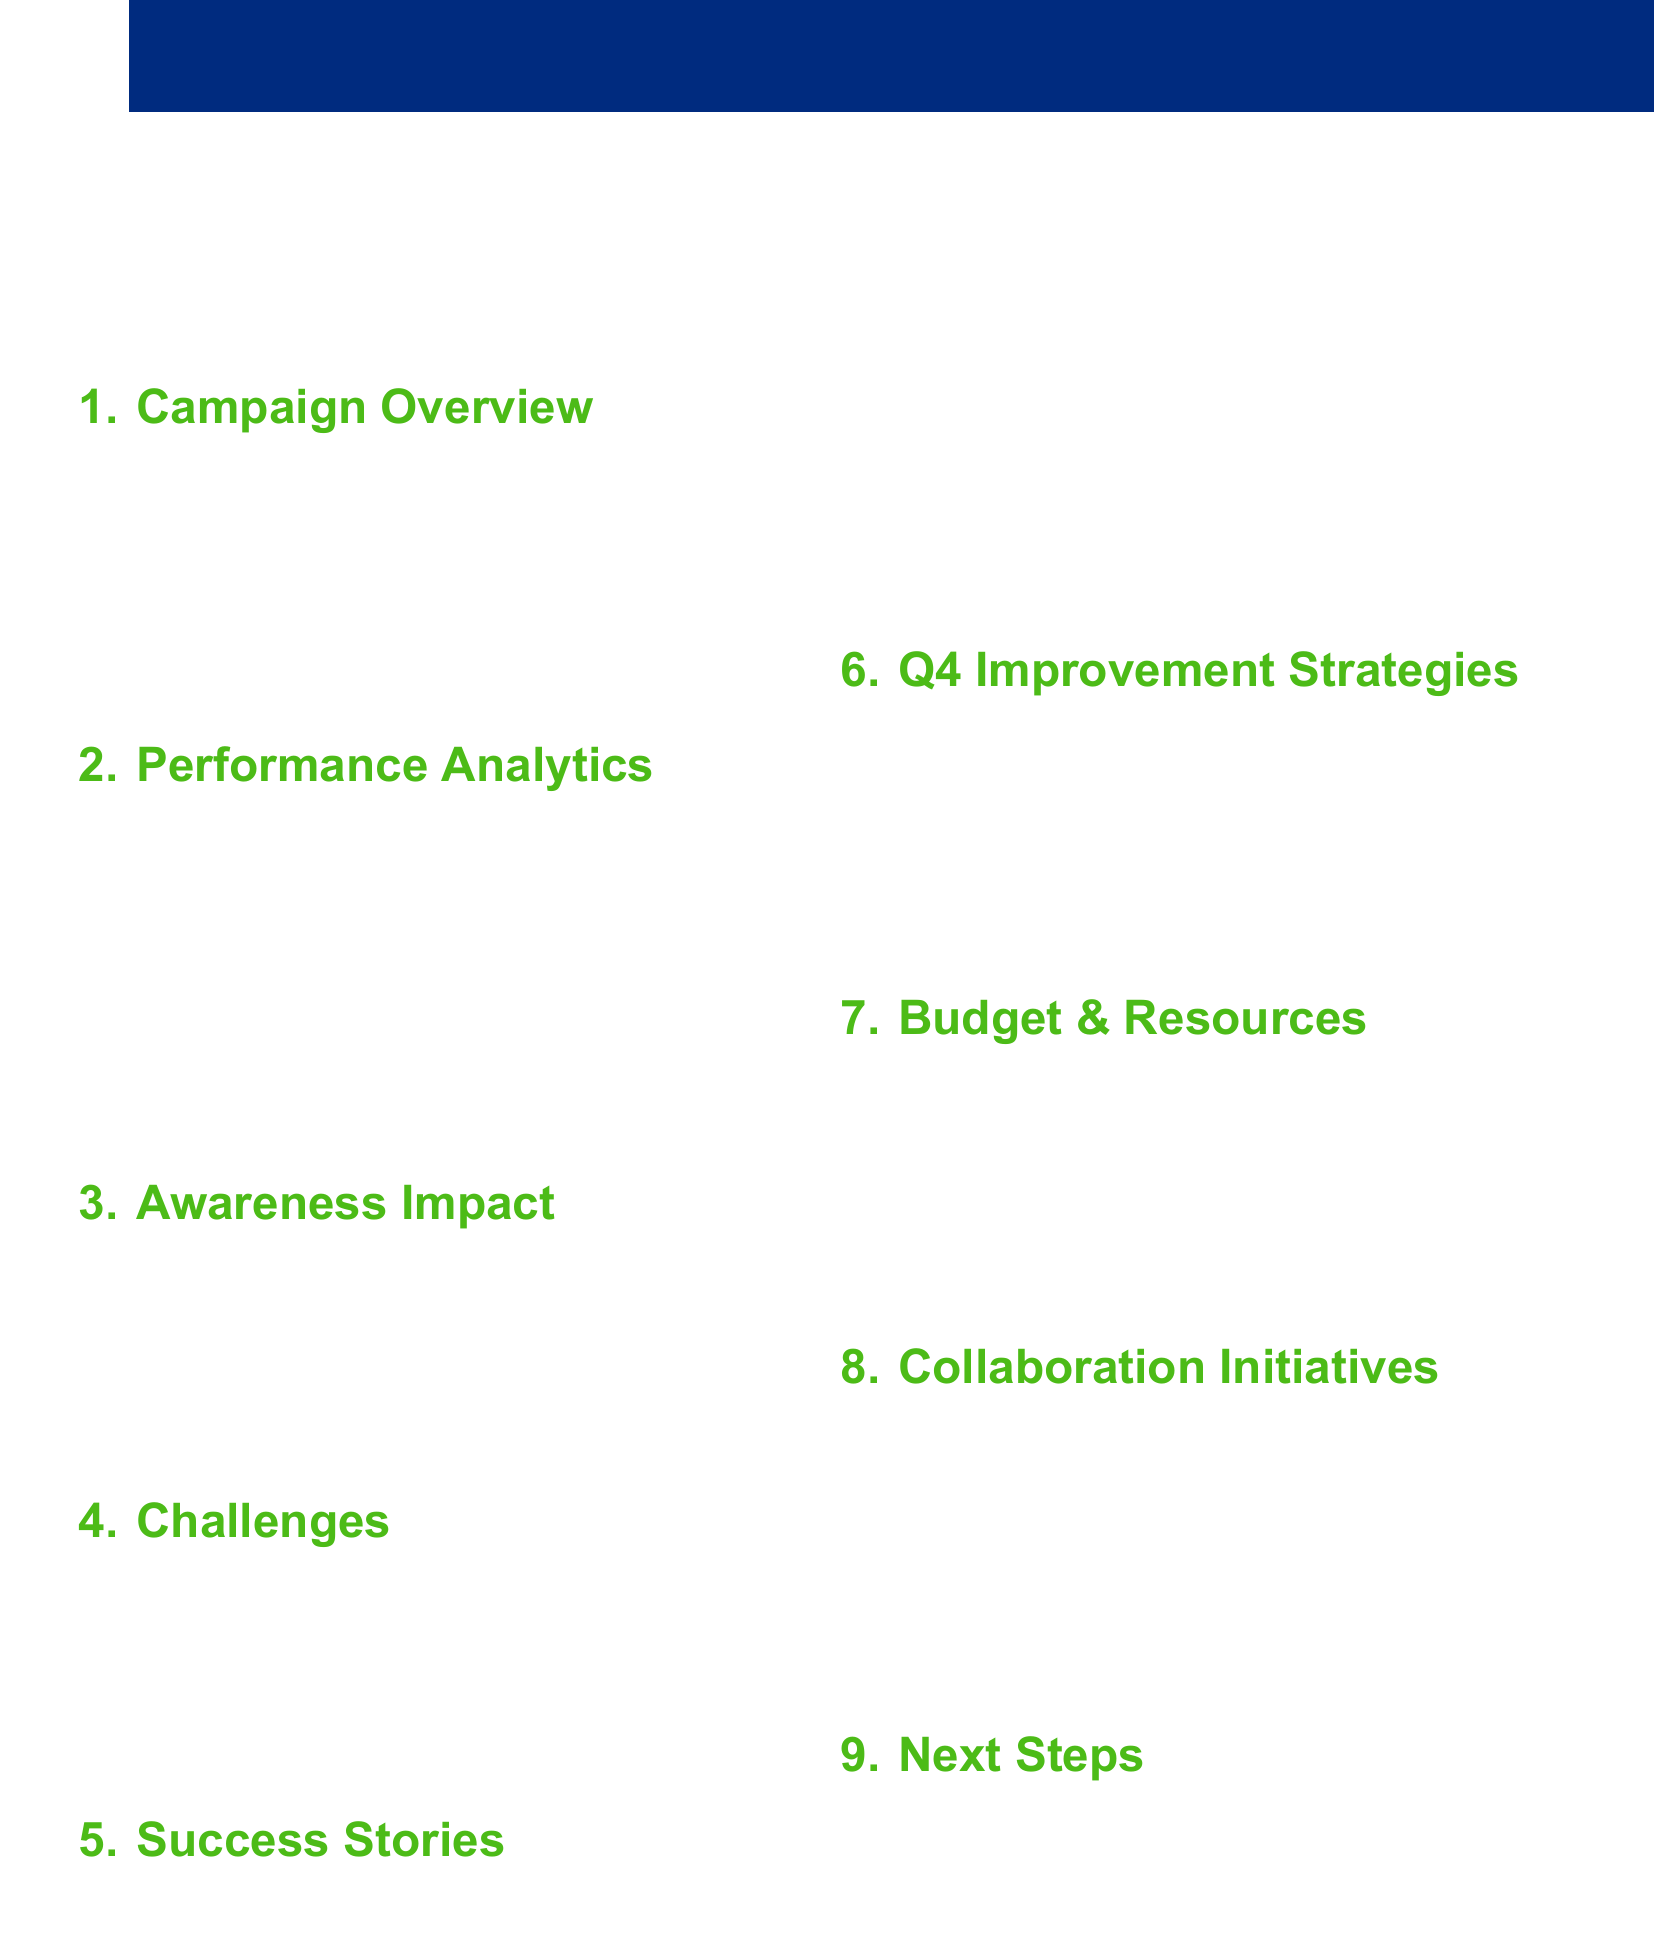what were the main corruption issues addressed? The document lists specific corruption issues tackled in Q3 2023 as procurement issues, judicial corruption, and environmental violations.
Answer: procurement issues, judicial corruption, environmental violations which platforms were used for the campaigns? The agenda specifies four social media platforms that were employed in the campaigns: Facebook, Twitter, Instagram, and TikTok.
Answer: Facebook, Twitter, Instagram, TikTok what were the most successful content types? The document highlights the types of content that received the most engagement, which include infographics, short videos, and live Q&As.
Answer: infographics, short videos, live Q&As what was the increase in reported corruption cases? The effectiveness report indicates an increase in corruption cases reported to the Procuraduría de la Ética Pública after the campaign.
Answer: increase in reported cases what collaboration initiatives are planned for Q4 2023? The document discusses several outreach strategies that will strengthen ties and educational content in collaboration with universities and regional partners.
Answer: Universidad de Costa Rica partnership how will artificial intelligence be used in Q4? The agenda suggests implementing AI-powered sentiment analysis to enhance content optimization in real-time for the upcoming quarter.
Answer: AI-powered sentiment analysis what was a significant challenge faced during the campaigns? The document mentions misinformation and inauthentic behavior as one of the major challenges encountered during the social media campaigns.
Answer: misinformation and inauthentic behavior how many success stories were summarized? The agenda outlines three specific success stories that illustrate the positive outcomes of the campaigns, resulting in various forms of citizen engagement.
Answer: three success stories 